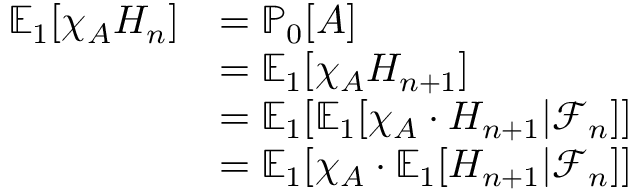<formula> <loc_0><loc_0><loc_500><loc_500>\begin{array} { r l } { \mathbb { E } _ { 1 } [ \chi _ { A } H _ { n } ] } & { = \mathbb { P } _ { 0 } [ A ] } \\ & { = \mathbb { E } _ { 1 } [ \chi _ { A } H _ { n + 1 } ] } \\ & { = \mathbb { E } _ { 1 } [ \mathbb { E } _ { 1 } [ \chi _ { A } \cdot H _ { n + 1 } | \mathcal { F } _ { n } ] ] } \\ & { = \mathbb { E } _ { 1 } [ \chi _ { A } \cdot \mathbb { E } _ { 1 } [ H _ { n + 1 } | \mathcal { F } _ { n } ] ] } \end{array}</formula> 